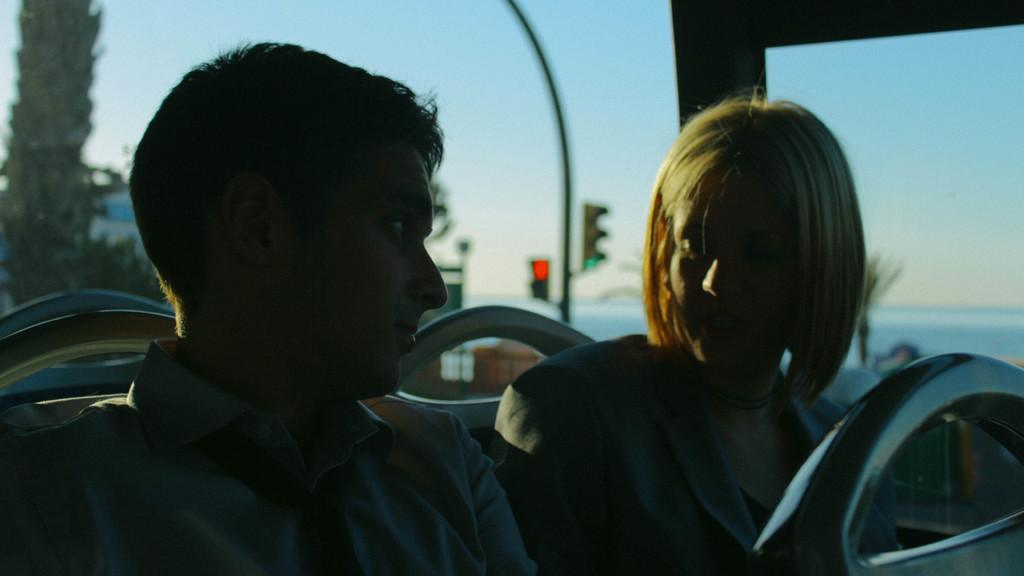How many people are present in the image? There are two people, a man and a woman, present in the image. What are the man and woman doing in the image? The man and woman are sitting inside a vehicle. What can be seen in the background of the image? There is a tree, a traffic signal, a light pole, and the sky visible in the background of the image. What type of ornament is hanging from the pipe in the box in the image? There is no ornament, pipe, or box present in the image. 